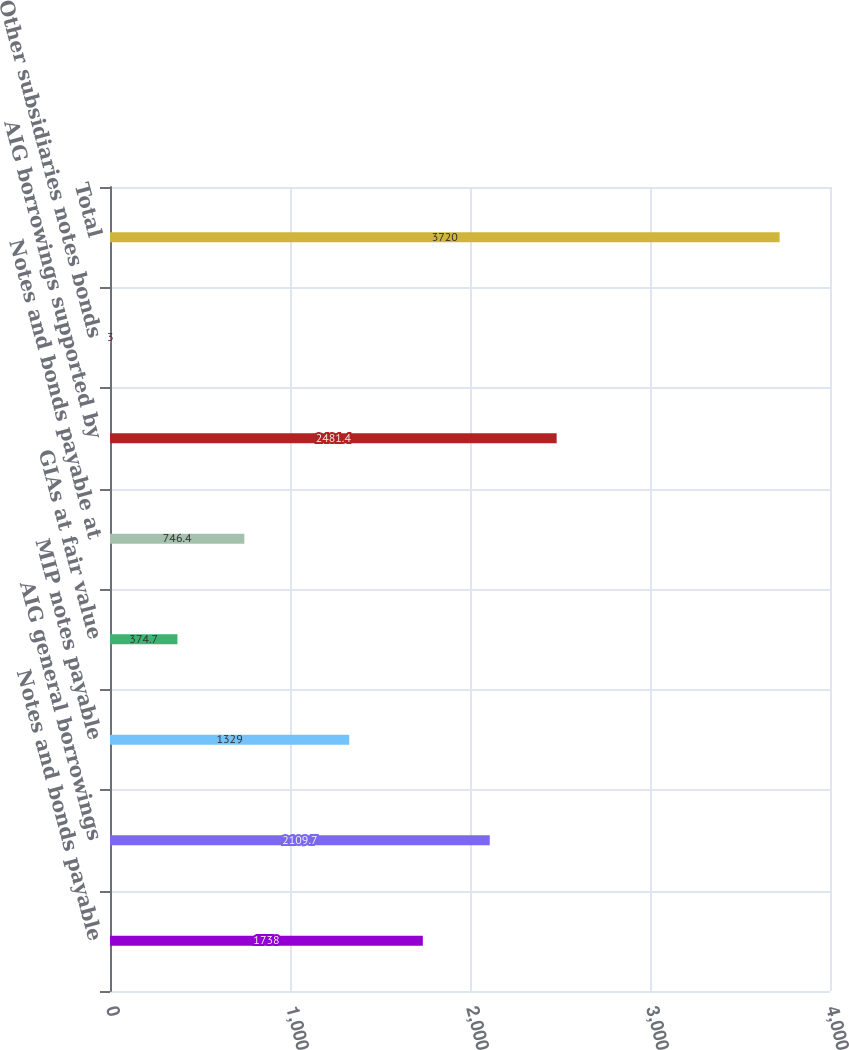Convert chart to OTSL. <chart><loc_0><loc_0><loc_500><loc_500><bar_chart><fcel>Notes and bonds payable<fcel>AIG general borrowings<fcel>MIP notes payable<fcel>GIAs at fair value<fcel>Notes and bonds payable at<fcel>AIG borrowings supported by<fcel>Other subsidiaries notes bonds<fcel>Total<nl><fcel>1738<fcel>2109.7<fcel>1329<fcel>374.7<fcel>746.4<fcel>2481.4<fcel>3<fcel>3720<nl></chart> 